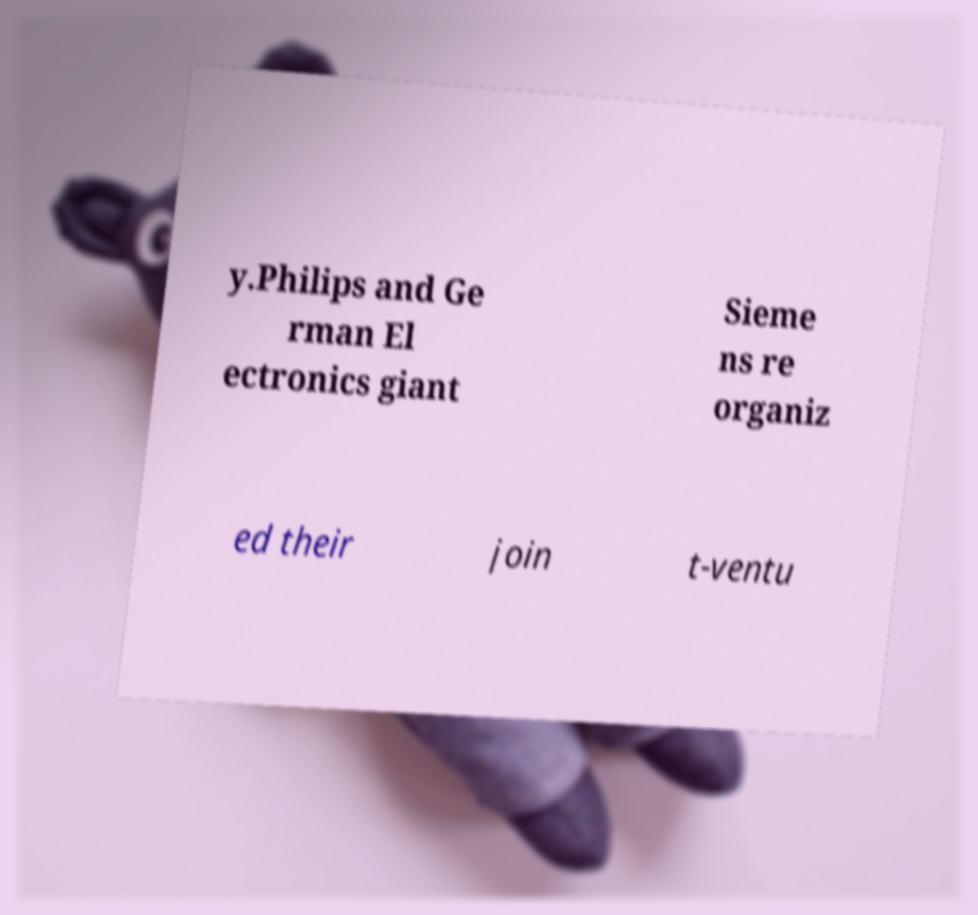There's text embedded in this image that I need extracted. Can you transcribe it verbatim? y.Philips and Ge rman El ectronics giant Sieme ns re organiz ed their join t-ventu 